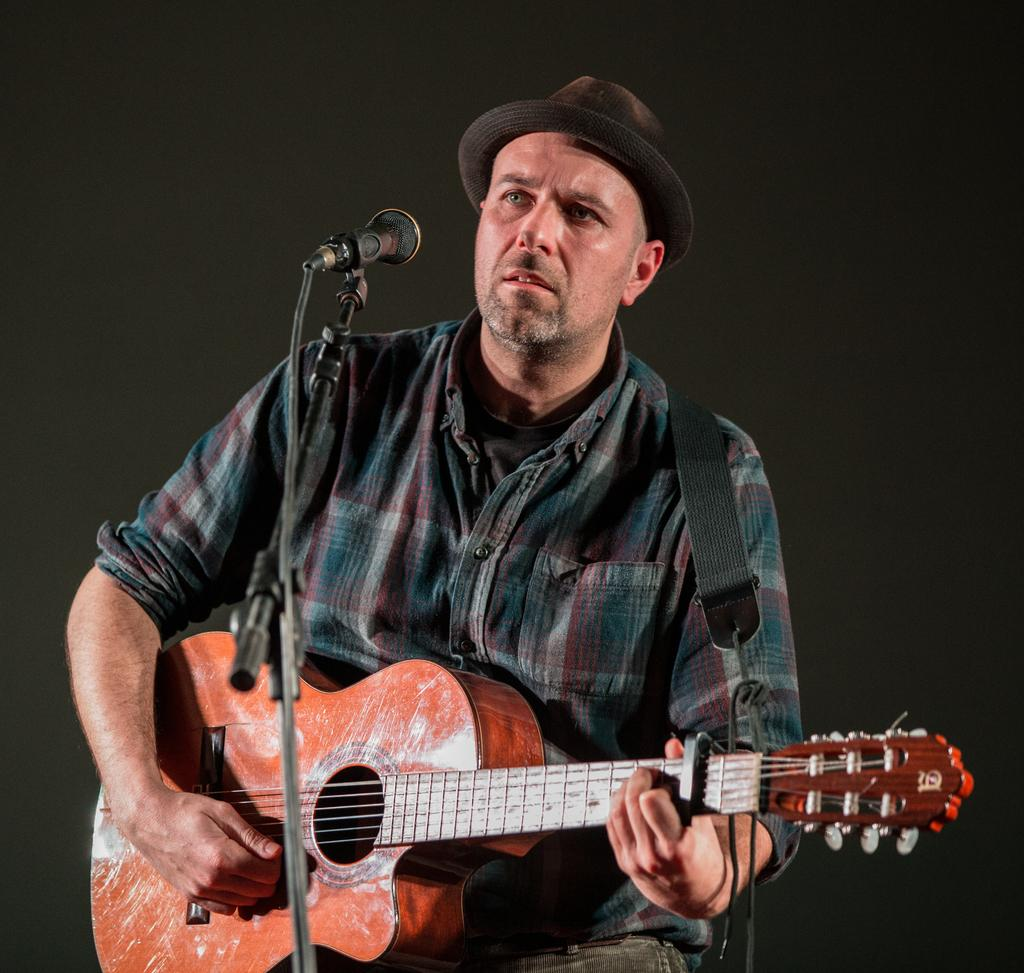What is the main subject of the image? There is a man in the image. What is the man doing in the image? The man is sitting on a chair and playing the guitar. What object is in front of the man? There is a microphone in front of the man. What instrument is the man holding? The man is holding a guitar. How many minutes does it take for the man to play the drum in the image? There is no drum present in the image, and the man is playing the guitar, not a drum. 